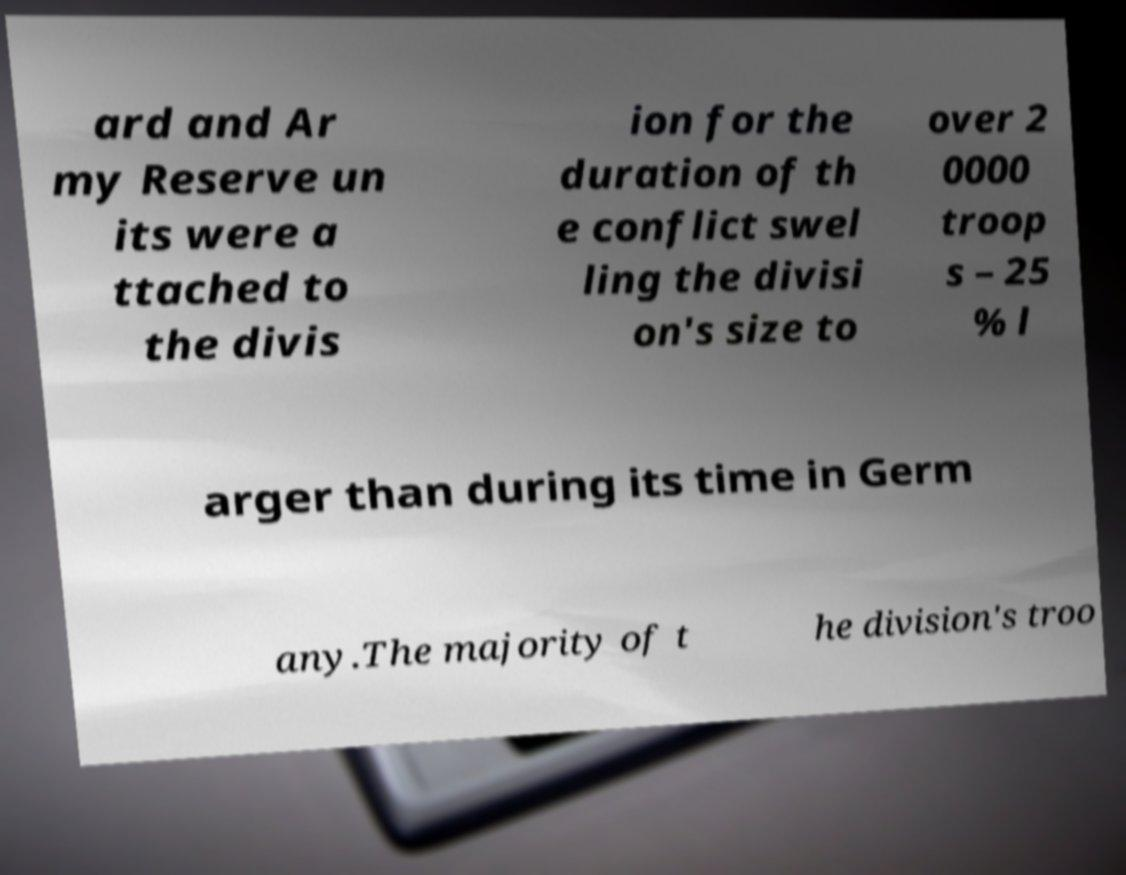Can you read and provide the text displayed in the image?This photo seems to have some interesting text. Can you extract and type it out for me? ard and Ar my Reserve un its were a ttached to the divis ion for the duration of th e conflict swel ling the divisi on's size to over 2 0000 troop s – 25 % l arger than during its time in Germ any.The majority of t he division's troo 